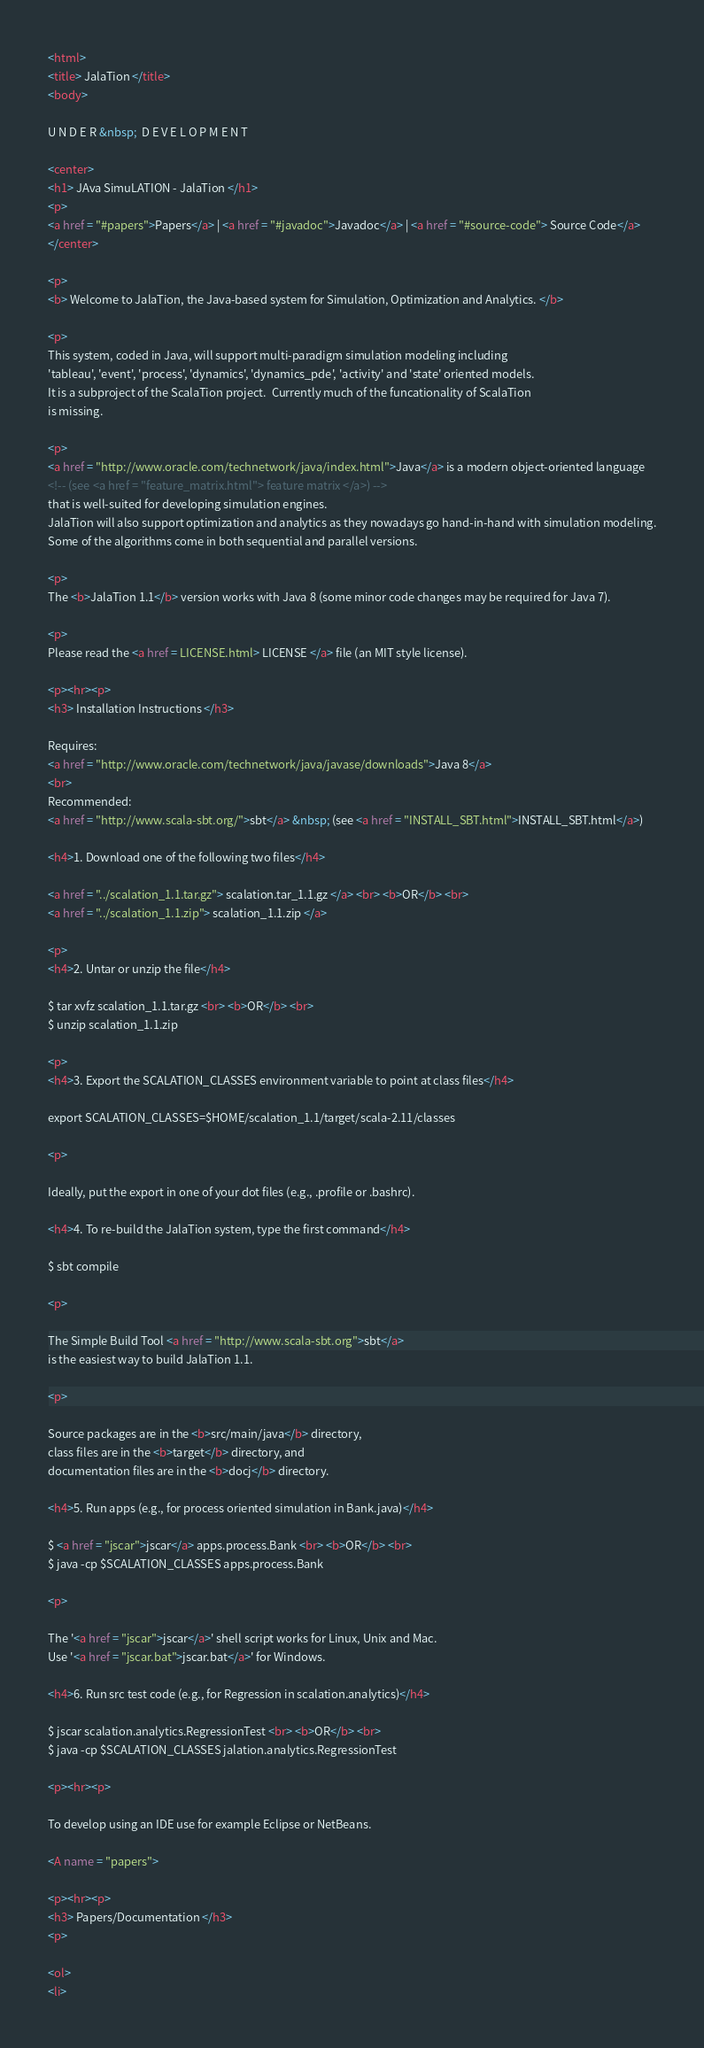<code> <loc_0><loc_0><loc_500><loc_500><_HTML_><html>
<title> JalaTion </title>
<body>

U N D E R &nbsp;  D E V E L O P M E N T 

<center>
<h1> JAva SimuLATION - JalaTion </h1>
<p>
<a href = "#papers">Papers</a> | <a href = "#javadoc">Javadoc</a> | <a href = "#source-code"> Source Code</a>
</center>

<p>
<b> Welcome to JalaTion, the Java-based system for Simulation, Optimization and Analytics. </b>

<p>
This system, coded in Java, will support multi-paradigm simulation modeling including
'tableau', 'event', 'process', 'dynamics', 'dynamics_pde', 'activity' and 'state' oriented models.
It is a subproject of the ScalaTion project.  Currently much of the funcationality of ScalaTion
is missing.

<p>
<a href = "http://www.oracle.com/technetwork/java/index.html">Java</a> is a modern object-oriented language
<!-- (see <a href = "feature_matrix.html"> feature matrix </a>) -->
that is well-suited for developing simulation engines.
JalaTion will also support optimization and analytics as they nowadays go hand-in-hand with simulation modeling.
Some of the algorithms come in both sequential and parallel versions.

<p>
The <b>JalaTion 1.1</b> version works with Java 8 (some minor code changes may be required for Java 7).

<p>
Please read the <a href = LICENSE.html> LICENSE </a> file (an MIT style license).

<p><hr><p>
<h3> Installation Instructions </h3>

Requires:
<a href = "http://www.oracle.com/technetwork/java/javase/downloads">Java 8</a>
<br>
Recommended:
<a href = "http://www.scala-sbt.org/">sbt</a> &nbsp; (see <a href = "INSTALL_SBT.html">INSTALL_SBT.html</a>)

<h4>1. Download one of the following two files</h4>

<a href = "../scalation_1.1.tar.gz"> scalation.tar_1.1.gz </a> <br> <b>OR</b> <br>
<a href = "../scalation_1.1.zip"> scalation_1.1.zip </a>

<p>
<h4>2. Untar or unzip the file</h4>

$ tar xvfz scalation_1.1.tar.gz <br> <b>OR</b> <br>
$ unzip scalation_1.1.zip

<p>
<h4>3. Export the SCALATION_CLASSES environment variable to point at class files</h4>

export SCALATION_CLASSES=$HOME/scalation_1.1/target/scala-2.11/classes

<p>

Ideally, put the export in one of your dot files (e.g., .profile or .bashrc).

<h4>4. To re-build the JalaTion system, type the first command</h4>

$ sbt compile

<p>

The Simple Build Tool <a href = "http://www.scala-sbt.org">sbt</a>
is the easiest way to build JalaTion 1.1.

<p>

Source packages are in the <b>src/main/java</b> directory,
class files are in the <b>target</b> directory, and
documentation files are in the <b>docj</b> directory.

<h4>5. Run apps (e.g., for process oriented simulation in Bank.java)</h4>

$ <a href = "jscar">jscar</a> apps.process.Bank <br> <b>OR</b> <br>
$ java -cp $SCALATION_CLASSES apps.process.Bank

<p>

The '<a href = "jscar">jscar</a>' shell script works for Linux, Unix and Mac.
Use '<a href = "jscar.bat">jscar.bat</a>' for Windows.

<h4>6. Run src test code (e.g., for Regression in scalation.analytics)</h4>

$ jscar scalation.analytics.RegressionTest <br> <b>OR</b> <br>
$ java -cp $SCALATION_CLASSES jalation.analytics.RegressionTest

<p><hr><p>

To develop using an IDE use for example Eclipse or NetBeans.

<A name = "papers">

<p><hr><p>
<h3> Papers/Documentation </h3>
<p>

<ol>
<li></code> 